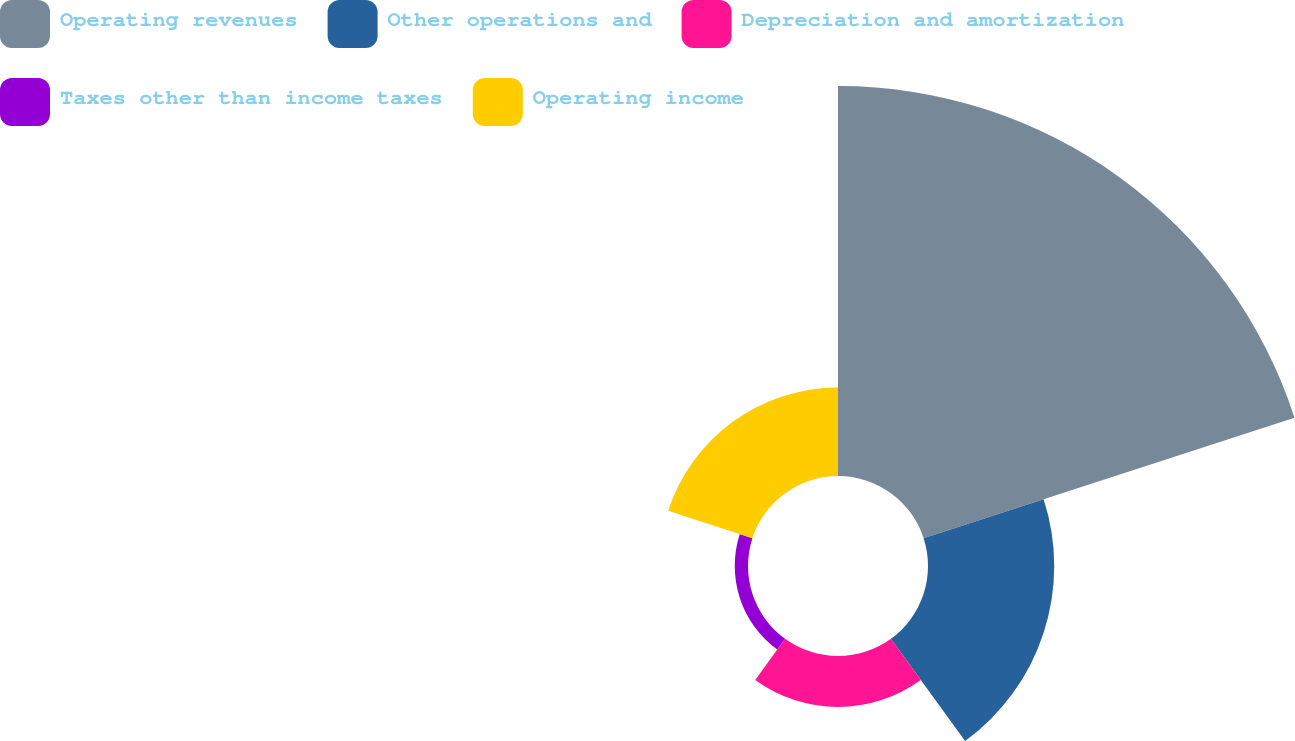<chart> <loc_0><loc_0><loc_500><loc_500><pie_chart><fcel>Operating revenues<fcel>Other operations and<fcel>Depreciation and amortization<fcel>Taxes other than income taxes<fcel>Operating income<nl><fcel>58.3%<fcel>18.87%<fcel>7.61%<fcel>1.98%<fcel>13.24%<nl></chart> 